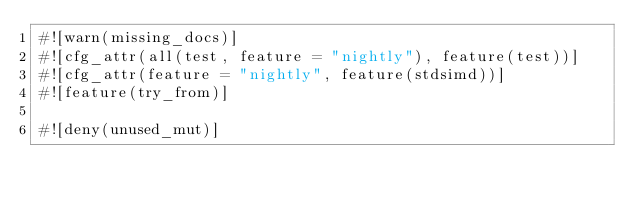Convert code to text. <code><loc_0><loc_0><loc_500><loc_500><_Rust_>#![warn(missing_docs)]
#![cfg_attr(all(test, feature = "nightly"), feature(test))]
#![cfg_attr(feature = "nightly", feature(stdsimd))]
#![feature(try_from)]

#![deny(unused_mut)]
</code> 